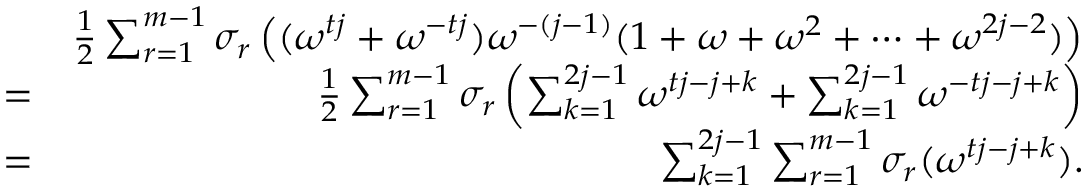<formula> <loc_0><loc_0><loc_500><loc_500>\begin{array} { r l r } & { \frac { 1 } { 2 } \sum _ { r = 1 } ^ { m - 1 } \sigma _ { r } \left ( ( \omega ^ { t j } + \omega ^ { - t j } ) \omega ^ { - ( j - 1 ) } ( 1 + \omega + \omega ^ { 2 } + \cdots + \omega ^ { 2 j - 2 } ) \right ) } \\ & { = } & { \frac { 1 } { 2 } \sum _ { r = 1 } ^ { m - 1 } \sigma _ { r } \left ( \sum _ { k = 1 } ^ { 2 j - 1 } \omega ^ { t j - j + k } + \sum _ { k = 1 } ^ { 2 j - 1 } \omega ^ { - t j - j + k } \right ) } \\ & { = } & { \sum _ { k = 1 } ^ { 2 j - 1 } \sum _ { r = 1 } ^ { m - 1 } \sigma _ { r } ( \omega ^ { t j - j + k } ) . } \end{array}</formula> 